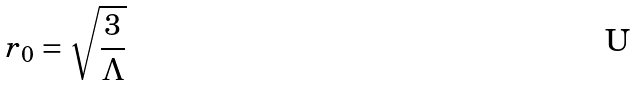<formula> <loc_0><loc_0><loc_500><loc_500>r _ { 0 } = \sqrt { \frac { 3 } { \Lambda } }</formula> 